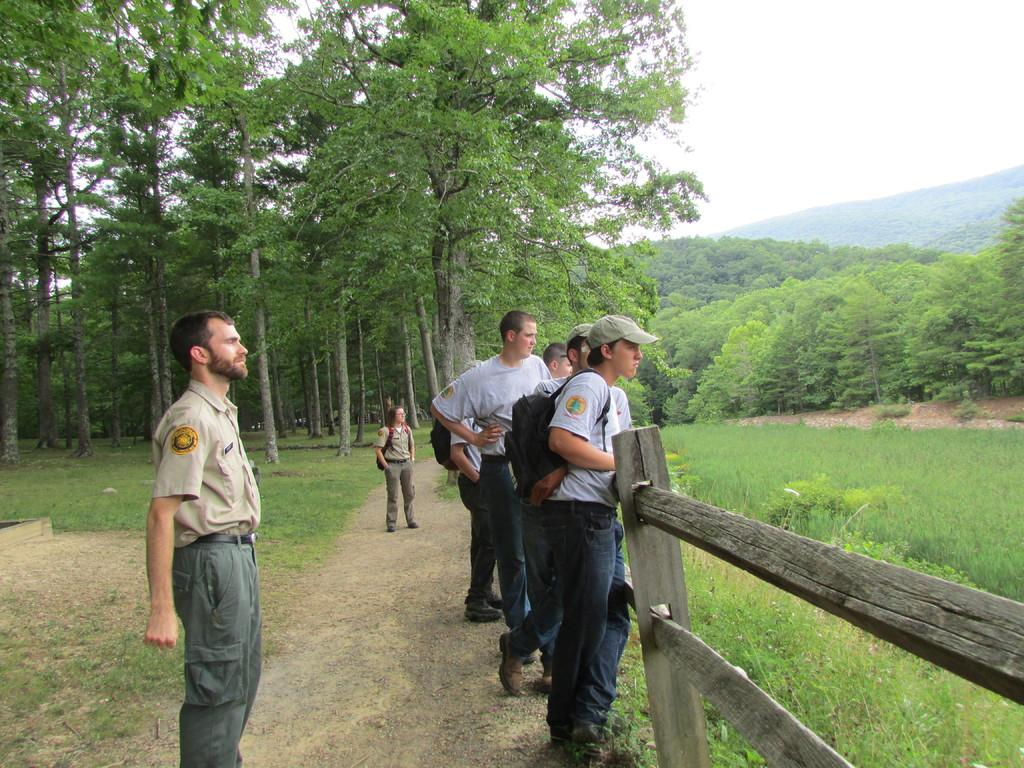What are the people in the image standing behind? The persons in the image are standing behind a wooden fence. What type of landscape surrounds the area where the people are standing? There is grassland on either side of the land. What can be seen in the background of the image? There are trees in the background. What is visible above the people and the wooden fence? The sky is visible above. What type of noise is the judge making in the image? There is no judge or noise present in the image. What reason do the people have for standing behind the wooden fence? The image does not provide information about the reason for the people standing behind the wooden fence. 